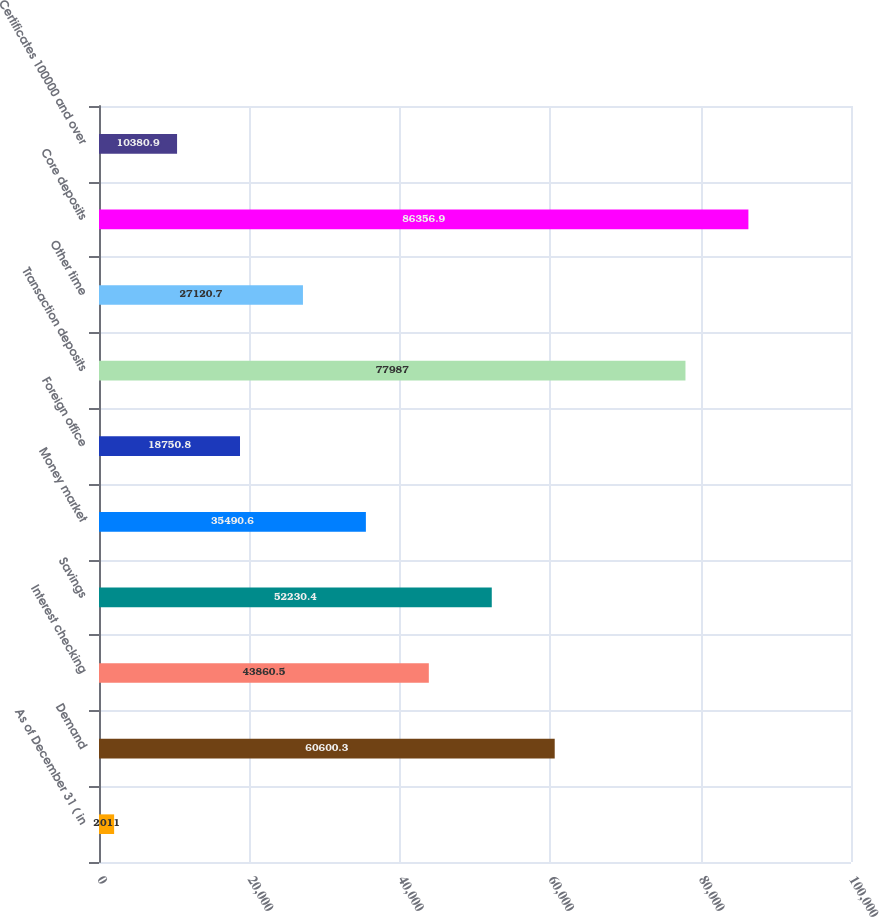<chart> <loc_0><loc_0><loc_500><loc_500><bar_chart><fcel>As of December 31 ( in<fcel>Demand<fcel>Interest checking<fcel>Savings<fcel>Money market<fcel>Foreign office<fcel>Transaction deposits<fcel>Other time<fcel>Core deposits<fcel>Certificates 100000 and over<nl><fcel>2011<fcel>60600.3<fcel>43860.5<fcel>52230.4<fcel>35490.6<fcel>18750.8<fcel>77987<fcel>27120.7<fcel>86356.9<fcel>10380.9<nl></chart> 